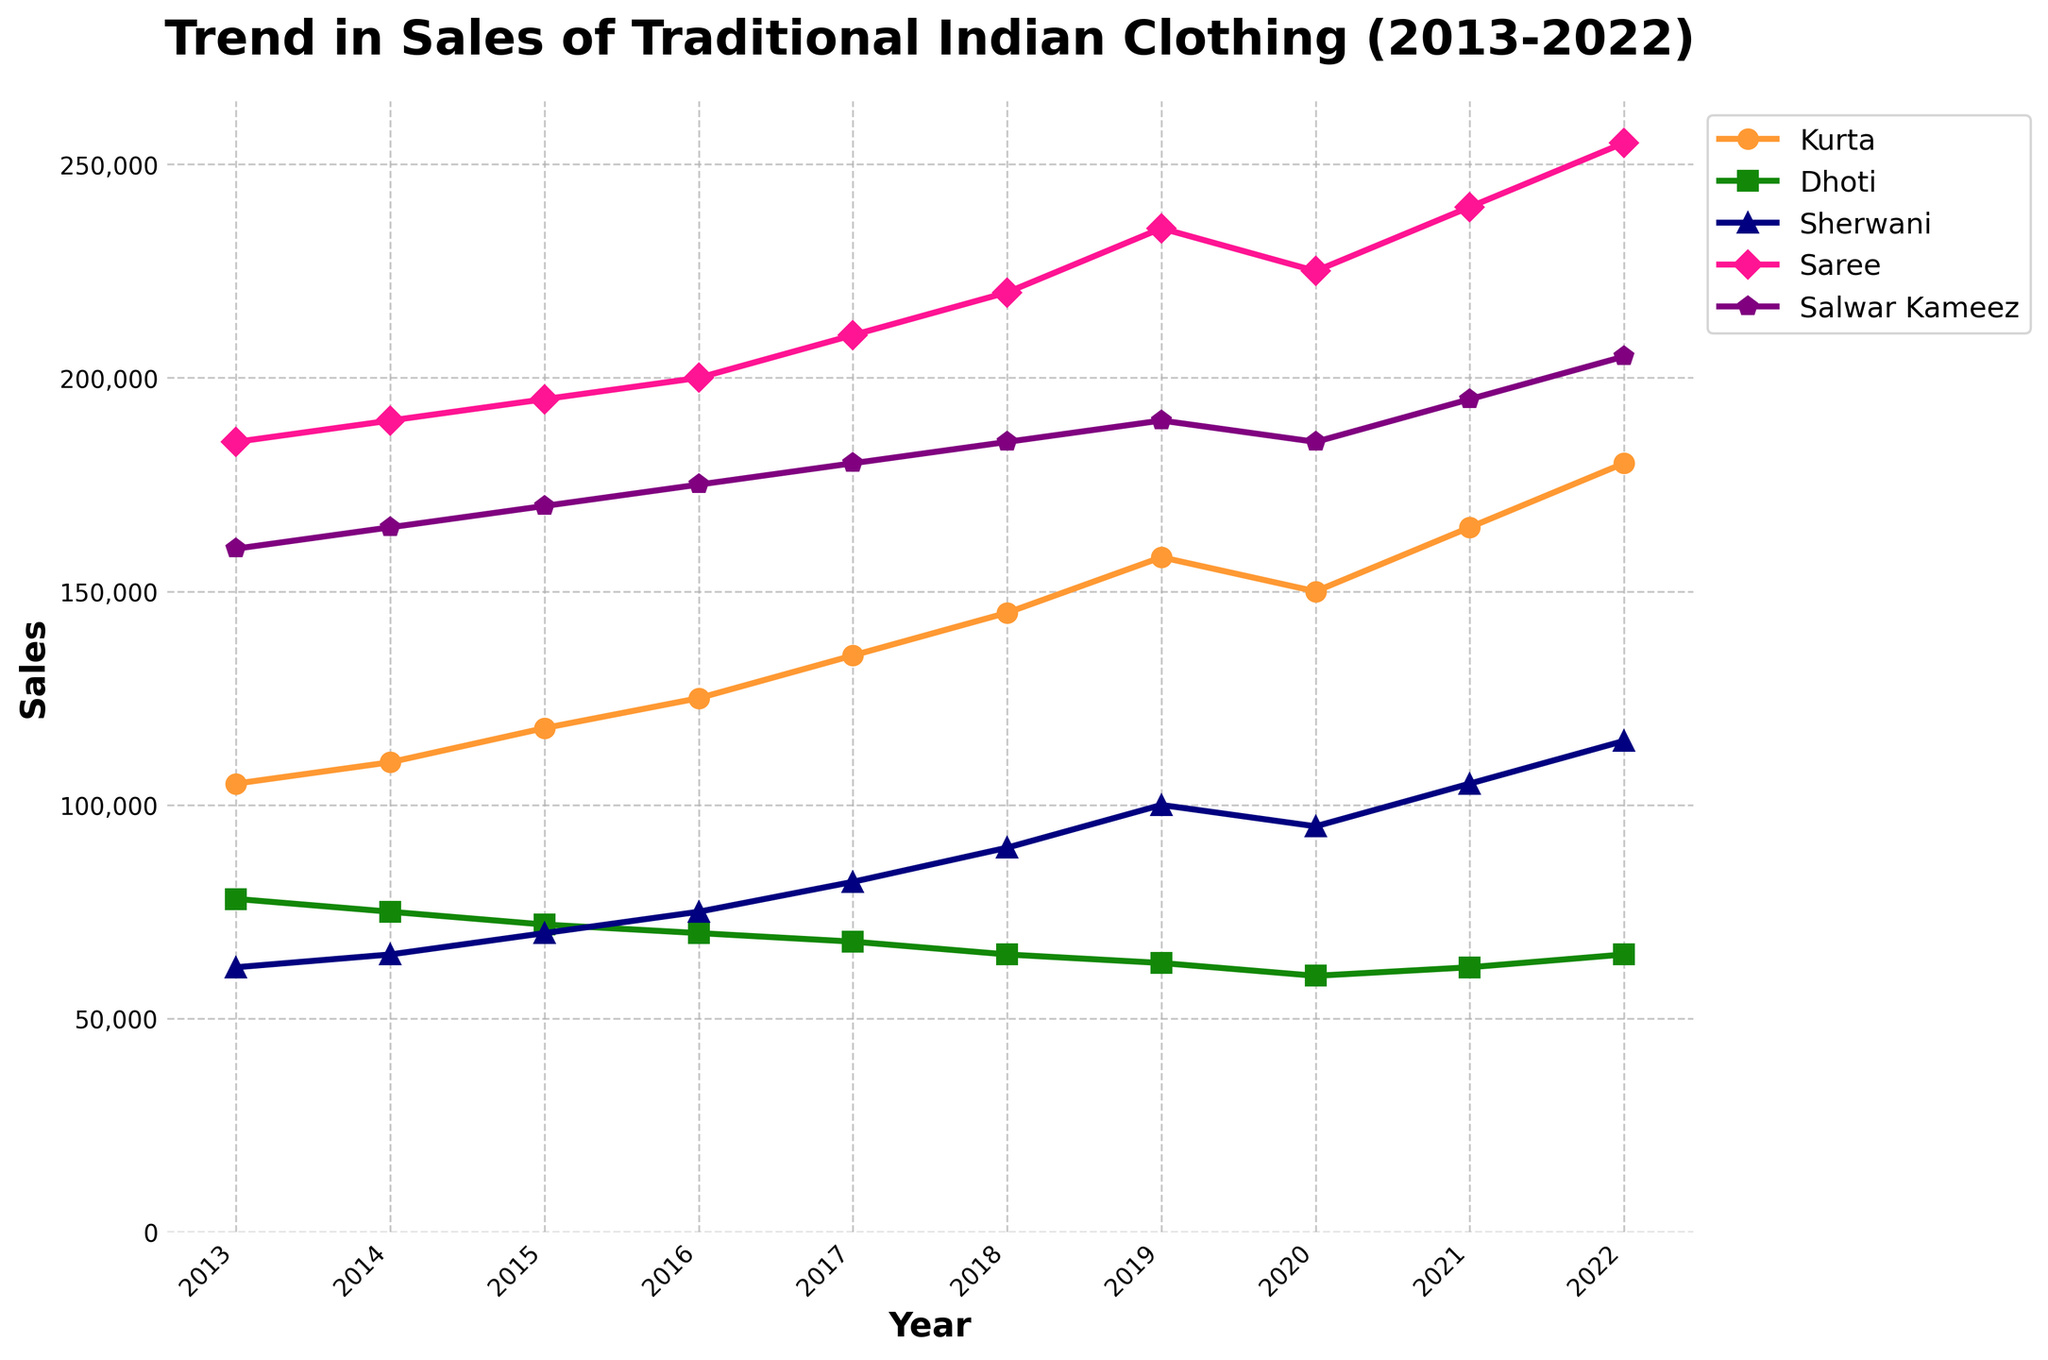Which garment had the highest sales in 2022? Looking at the figure for the year 2022, the garment with the highest line point is the Saree.
Answer: Saree How did the sales of Sherwani change from 2013 to 2022? The sales of Sherwani increased from 62,000 in 2013 to 115,000 in 2022. Calculating the difference: 115,000 - 62,000 = 53,000.
Answer: Increased by 53,000 Which year saw the lowest sales for Dhotis? Looking at the figure, the lowest point on the Dhoti line is in the year 2020.
Answer: 2020 What is the average sales of Kurta from 2018 to 2022? Summing the sales of Kurta from 2018 to 2022: 145,000 + 158,000 + 150,000 + 165,000 + 180,000 = 798,000. Dividing by the number of years (5): 798,000 / 5 = 159,600.
Answer: 159,600 Did any garment have a decline in sales between 2021 and 2022? Checking the sales figures between 2021 and 2022 for each garment, no garment shows a decline in sales during this period.
Answer: No Which garment experienced the largest increase in sales over the entire decade? Calculating the difference for each garment: Kurta: 180,000 - 105,000 = 75,000, Dhoti: 65,000 - 78,000 = -13,000, Sherwani: 115,000 - 62,000 = 53,000, Saree: 255,000 - 185,000 = 70,000, Salwar Kameez: 205,000 - 160,000 = 45,000. The largest increase is for Kurta.
Answer: Kurta How do the sales trends of Saree and Salwar Kameez compare? Both Saree and Salwar Kameez show an upward trend over the decade. The Saree line remains consistently higher than the Salwar Kameez line each year.
Answer: Both increased, Saree higher What was the combined sales for Saree and Salwar Kameez in 2013? Adding the sales for Saree and Salwar Kameez in 2013: 185,000 + 160,000 = 345,000.
Answer: 345,000 What was the sales trend for Dhoti from 2013 to 2022? The sales of Dhoti generally declined from 78,000 in 2013 to 65,000 in 2022, with minor fluctuations.
Answer: General decline In which year did Kurta surpass the 150,000 sales mark? Looking at the figure, Kurta surpassed the 150,000 sales mark in the year 2019.
Answer: 2019 